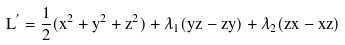Convert formula to latex. <formula><loc_0><loc_0><loc_500><loc_500>L ^ { ^ { \prime } } = \frac { 1 } { 2 } ( \dot { x ^ { 2 } } + \dot { y ^ { 2 } } + \dot { z ^ { 2 } } ) + \dot { \lambda _ { 1 } } ( y \dot { z } - z \dot { y } ) + \dot { \lambda _ { 2 } } ( z \dot { x } - x \dot { z } )</formula> 